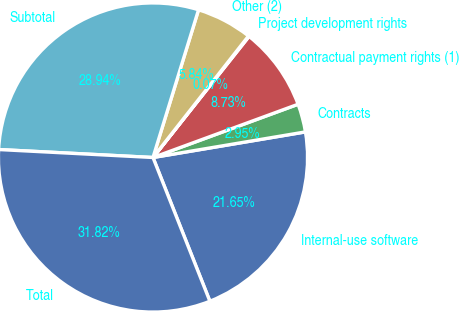Convert chart. <chart><loc_0><loc_0><loc_500><loc_500><pie_chart><fcel>Internal-use software<fcel>Contracts<fcel>Contractual payment rights (1)<fcel>Project development rights<fcel>Other (2)<fcel>Subtotal<fcel>Total<nl><fcel>21.65%<fcel>2.95%<fcel>8.73%<fcel>0.07%<fcel>5.84%<fcel>28.94%<fcel>31.82%<nl></chart> 